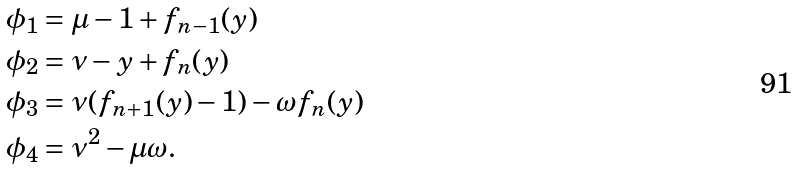Convert formula to latex. <formula><loc_0><loc_0><loc_500><loc_500>\phi _ { 1 } & = \mu - 1 + f _ { n - 1 } ( y ) \\ \phi _ { 2 } & = \nu - y + f _ { n } ( y ) \\ \phi _ { 3 } & = \nu ( f _ { n + 1 } ( y ) - 1 ) - \omega f _ { n } ( y ) \\ \phi _ { 4 } & = \nu ^ { 2 } - \mu \omega .</formula> 